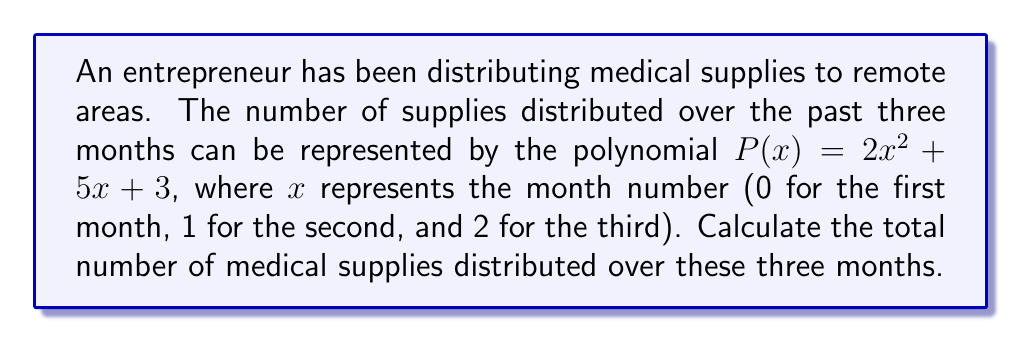Give your solution to this math problem. To solve this problem, we need to evaluate the polynomial for each month and sum the results:

1. For the first month (x = 0):
   $P(0) = 2(0)^2 + 5(0) + 3 = 3$

2. For the second month (x = 1):
   $P(1) = 2(1)^2 + 5(1) + 3 = 2 + 5 + 3 = 10$

3. For the third month (x = 2):
   $P(2) = 2(2)^2 + 5(2) + 3 = 8 + 10 + 3 = 21$

4. Sum the results:
   Total supplies = $P(0) + P(1) + P(2) = 3 + 10 + 21 = 34$

Therefore, the total number of medical supplies distributed over the three months is 34.
Answer: 34 supplies 